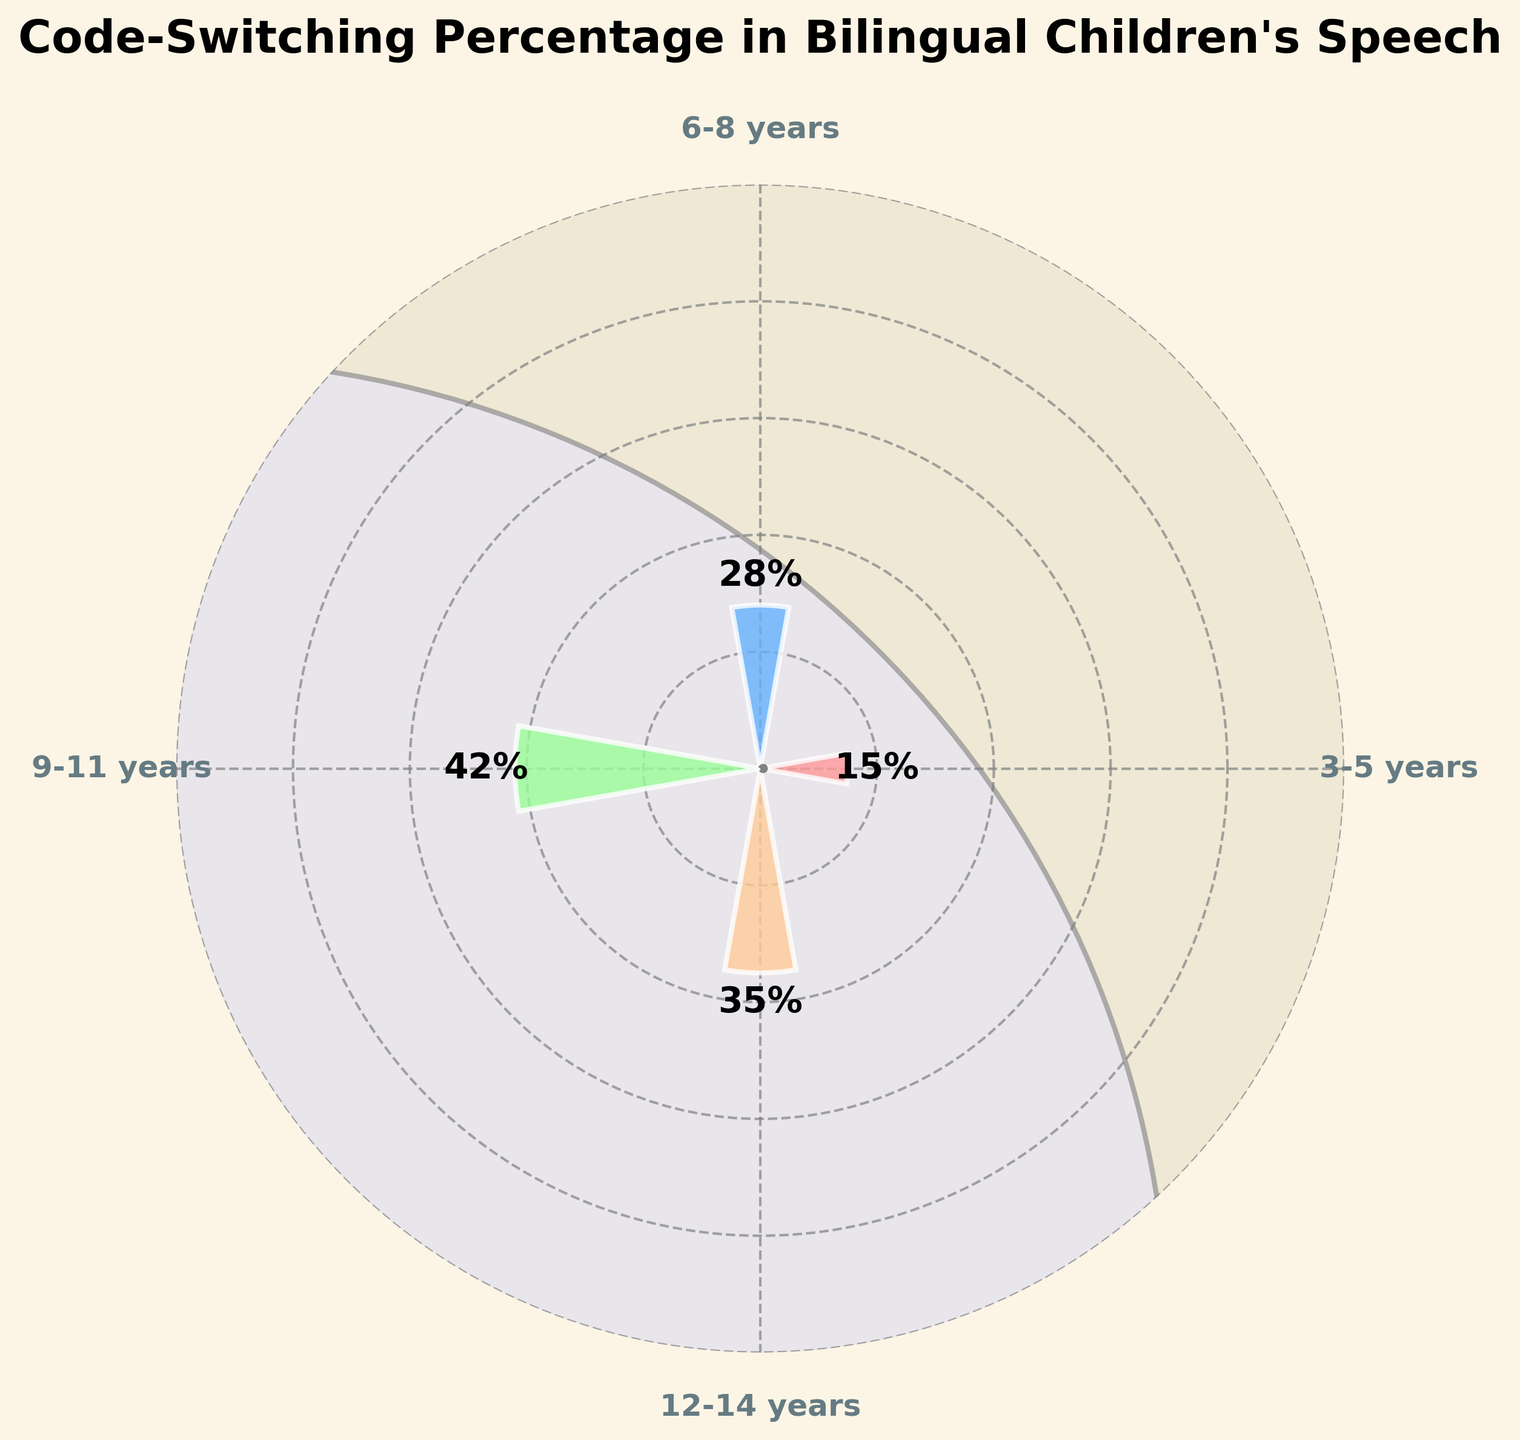What is the title of the figure? The title is generally written at the top of the figure. Here, it is placed above the gauge chart and reads, "Code-Switching Percentage in Bilingual Children's Speech".
Answer: Code-Switching Percentage in Bilingual Children's Speech How many age groups are represented in the figure? The figure uses the x-axis to label different age groups. Counting the unique labels, we see there are four age groups: 3-5 years, 6-8 years, 9-11 years, and 12-14 years.
Answer: Four Which age group has the highest percentage of code-switching? By observing the height of the bars corresponding to each age group, the tallest bar, marked with 42%, belongs to the 9-11 years group.
Answer: 9-11 years What is the difference in code-switching percentage between the 9-11 years group and the 3-5 years group? The 9-11 years group has a percentage of 42%, while the 3-5 years group has 15%. The difference is calculated as 42% - 15%.
Answer: 27% What is the average code-switching percentage across all age groups? Adding the percentages for all age groups (15% + 28% + 42% + 35%) gives 120%. Dividing by the number of groups (4) yields the average: 120% / 4.
Answer: 30% Which age group shows a decrease in the code-switching percentage compared to the previous age group? Comparing the percentages between consecutive age groups (15%, 28%, 42%, 35%), the decrease is from 42% (9-11 years) to 35% (12-14 years), which can be observed by a shorter bar and the corresponding value.
Answer: 12-14 years What is the total sum of the code-switching percentages for the age groups 6-8 years and 12-14 years? Adding the percentages specifically for these two age groups: 28% (6-8 years) + 35% (12-14 years).
Answer: 63% How much higher is the code-switching percentage for the 6-8 years group compared to the 3-5 years group? Subtracting the percentage of the 3-5 years (15%) from that of the 6-8 years (28%) gives the difference.
Answer: 13% What visual elements are used to enhance the appearance of the gauge chart? Noting the overall design, including the circular background, decorative arcs, polar axes, and color-coded bars with white edges and a specific color scheme for each bar, enhances the visualization.
Answer: Circular background, decorative arcs, color-coded bars What is the range of the y-axis in the gauge chart? The y-axis range is shown along the radial lines of the polar chart, marked from 0% to 100%. It is divided into increments of 20%.
Answer: 0% to 100% 